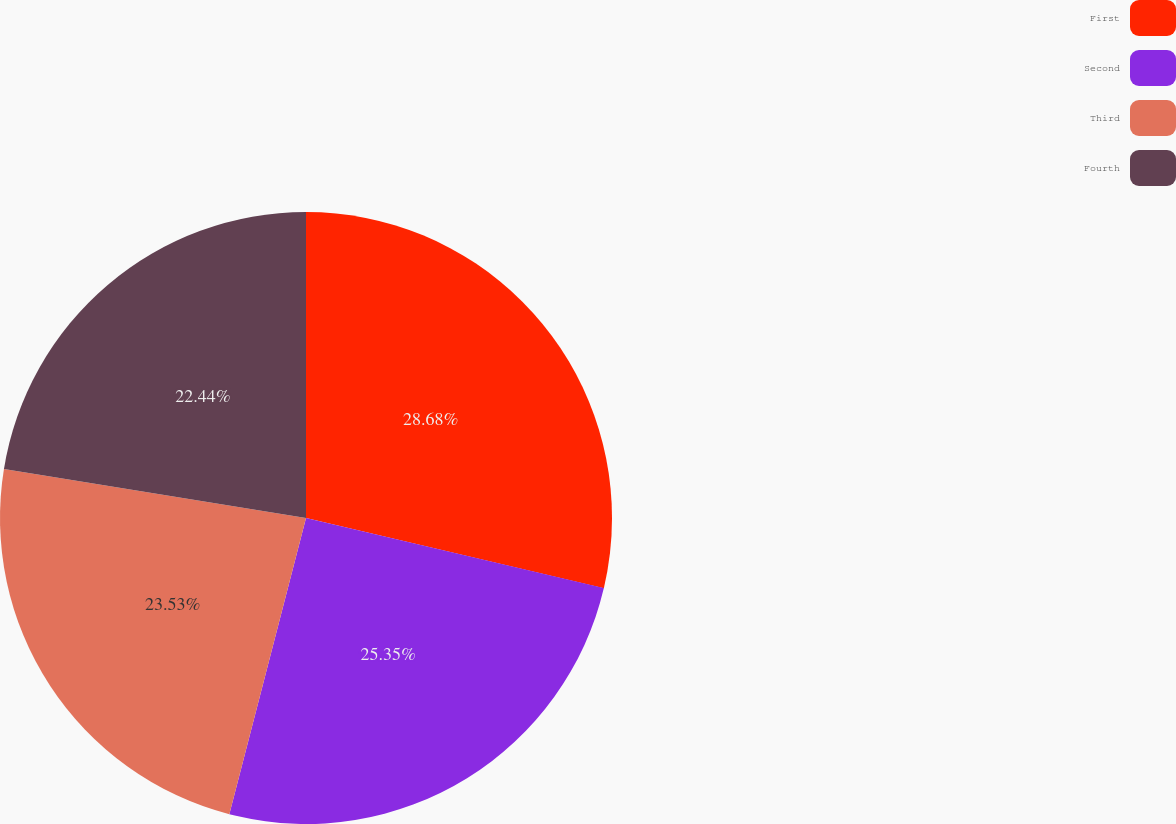Convert chart. <chart><loc_0><loc_0><loc_500><loc_500><pie_chart><fcel>First<fcel>Second<fcel>Third<fcel>Fourth<nl><fcel>28.68%<fcel>25.35%<fcel>23.53%<fcel>22.44%<nl></chart> 